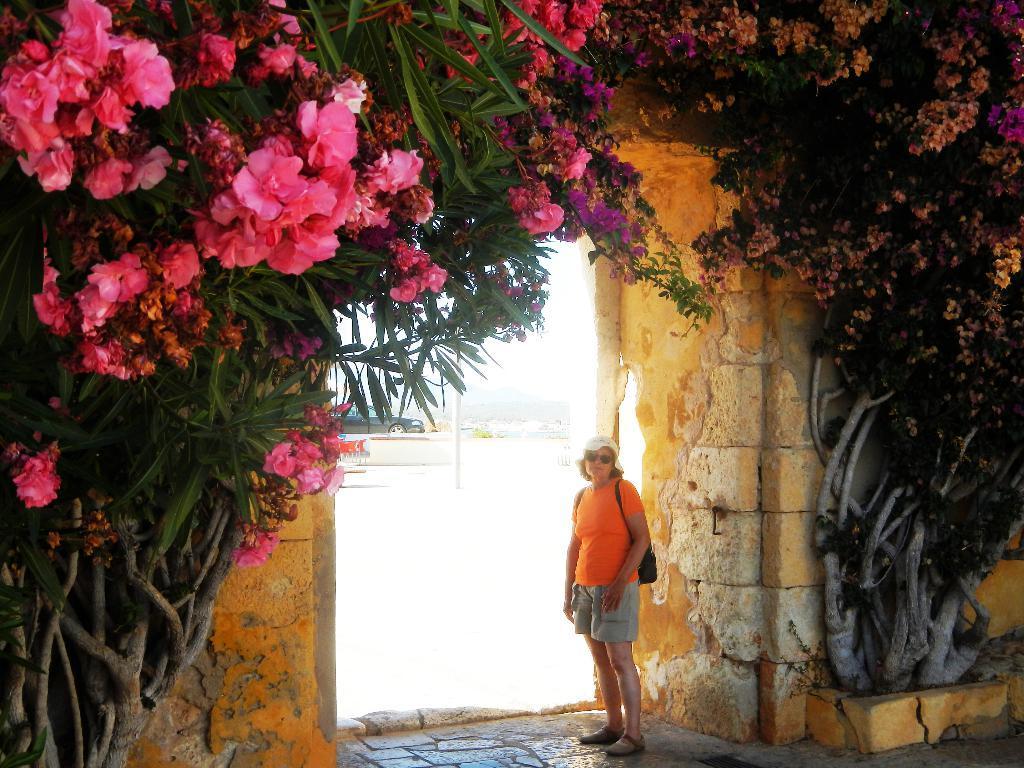How would you summarize this image in a sentence or two? In this picture there is a woman standing and carrying a bag and we can see flowers, trees and wall. In the background of the image we can see pole and car. 